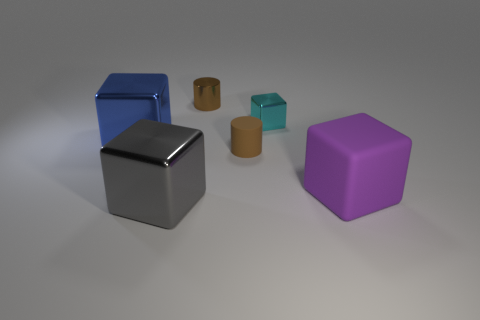What shape is the gray object? cube 